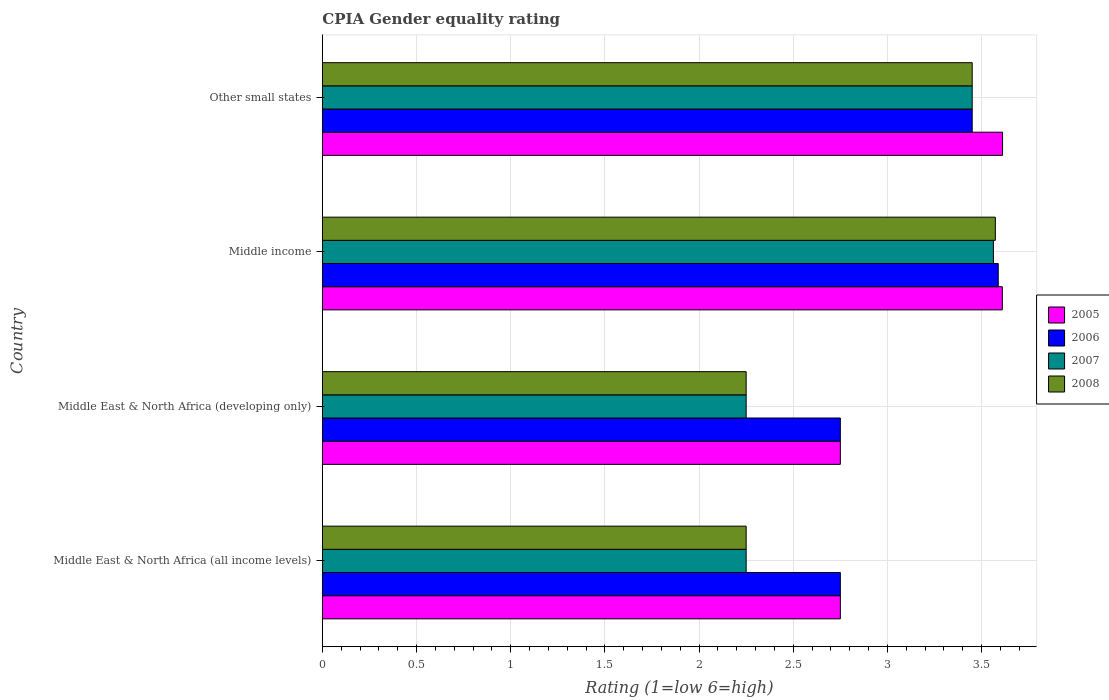How many groups of bars are there?
Offer a very short reply. 4. Are the number of bars per tick equal to the number of legend labels?
Keep it short and to the point. Yes. Are the number of bars on each tick of the Y-axis equal?
Provide a succinct answer. Yes. How many bars are there on the 2nd tick from the bottom?
Provide a short and direct response. 4. What is the label of the 1st group of bars from the top?
Provide a short and direct response. Other small states. What is the CPIA rating in 2008 in Middle East & North Africa (all income levels)?
Offer a very short reply. 2.25. Across all countries, what is the maximum CPIA rating in 2006?
Your answer should be compact. 3.59. Across all countries, what is the minimum CPIA rating in 2006?
Your answer should be compact. 2.75. In which country was the CPIA rating in 2008 minimum?
Provide a short and direct response. Middle East & North Africa (all income levels). What is the total CPIA rating in 2008 in the graph?
Offer a terse response. 11.52. What is the difference between the CPIA rating in 2005 in Middle East & North Africa (developing only) and that in Other small states?
Keep it short and to the point. -0.86. What is the difference between the CPIA rating in 2006 in Other small states and the CPIA rating in 2005 in Middle East & North Africa (developing only)?
Give a very brief answer. 0.7. What is the average CPIA rating in 2006 per country?
Offer a very short reply. 3.13. Is the difference between the CPIA rating in 2008 in Middle East & North Africa (all income levels) and Middle East & North Africa (developing only) greater than the difference between the CPIA rating in 2007 in Middle East & North Africa (all income levels) and Middle East & North Africa (developing only)?
Make the answer very short. No. What is the difference between the highest and the second highest CPIA rating in 2006?
Make the answer very short. 0.14. What is the difference between the highest and the lowest CPIA rating in 2005?
Offer a terse response. 0.86. Is it the case that in every country, the sum of the CPIA rating in 2007 and CPIA rating in 2006 is greater than the sum of CPIA rating in 2005 and CPIA rating in 2008?
Keep it short and to the point. Yes. What does the 1st bar from the top in Middle East & North Africa (developing only) represents?
Make the answer very short. 2008. What does the 4th bar from the bottom in Other small states represents?
Ensure brevity in your answer.  2008. Is it the case that in every country, the sum of the CPIA rating in 2006 and CPIA rating in 2008 is greater than the CPIA rating in 2007?
Your response must be concise. Yes. How many bars are there?
Ensure brevity in your answer.  16. What is the difference between two consecutive major ticks on the X-axis?
Your answer should be very brief. 0.5. Are the values on the major ticks of X-axis written in scientific E-notation?
Give a very brief answer. No. Does the graph contain any zero values?
Offer a terse response. No. Where does the legend appear in the graph?
Give a very brief answer. Center right. What is the title of the graph?
Provide a short and direct response. CPIA Gender equality rating. What is the Rating (1=low 6=high) in 2005 in Middle East & North Africa (all income levels)?
Provide a short and direct response. 2.75. What is the Rating (1=low 6=high) in 2006 in Middle East & North Africa (all income levels)?
Provide a short and direct response. 2.75. What is the Rating (1=low 6=high) of 2007 in Middle East & North Africa (all income levels)?
Ensure brevity in your answer.  2.25. What is the Rating (1=low 6=high) in 2008 in Middle East & North Africa (all income levels)?
Give a very brief answer. 2.25. What is the Rating (1=low 6=high) in 2005 in Middle East & North Africa (developing only)?
Offer a very short reply. 2.75. What is the Rating (1=low 6=high) of 2006 in Middle East & North Africa (developing only)?
Make the answer very short. 2.75. What is the Rating (1=low 6=high) in 2007 in Middle East & North Africa (developing only)?
Provide a short and direct response. 2.25. What is the Rating (1=low 6=high) in 2008 in Middle East & North Africa (developing only)?
Ensure brevity in your answer.  2.25. What is the Rating (1=low 6=high) in 2005 in Middle income?
Make the answer very short. 3.61. What is the Rating (1=low 6=high) of 2006 in Middle income?
Offer a terse response. 3.59. What is the Rating (1=low 6=high) in 2007 in Middle income?
Your answer should be compact. 3.56. What is the Rating (1=low 6=high) in 2008 in Middle income?
Provide a succinct answer. 3.57. What is the Rating (1=low 6=high) in 2005 in Other small states?
Offer a very short reply. 3.61. What is the Rating (1=low 6=high) of 2006 in Other small states?
Ensure brevity in your answer.  3.45. What is the Rating (1=low 6=high) of 2007 in Other small states?
Provide a short and direct response. 3.45. What is the Rating (1=low 6=high) of 2008 in Other small states?
Offer a terse response. 3.45. Across all countries, what is the maximum Rating (1=low 6=high) of 2005?
Offer a terse response. 3.61. Across all countries, what is the maximum Rating (1=low 6=high) in 2006?
Provide a short and direct response. 3.59. Across all countries, what is the maximum Rating (1=low 6=high) in 2007?
Keep it short and to the point. 3.56. Across all countries, what is the maximum Rating (1=low 6=high) of 2008?
Offer a very short reply. 3.57. Across all countries, what is the minimum Rating (1=low 6=high) in 2005?
Keep it short and to the point. 2.75. Across all countries, what is the minimum Rating (1=low 6=high) of 2006?
Your answer should be very brief. 2.75. Across all countries, what is the minimum Rating (1=low 6=high) of 2007?
Ensure brevity in your answer.  2.25. Across all countries, what is the minimum Rating (1=low 6=high) in 2008?
Your answer should be compact. 2.25. What is the total Rating (1=low 6=high) in 2005 in the graph?
Give a very brief answer. 12.72. What is the total Rating (1=low 6=high) of 2006 in the graph?
Ensure brevity in your answer.  12.54. What is the total Rating (1=low 6=high) in 2007 in the graph?
Make the answer very short. 11.51. What is the total Rating (1=low 6=high) in 2008 in the graph?
Your response must be concise. 11.52. What is the difference between the Rating (1=low 6=high) in 2005 in Middle East & North Africa (all income levels) and that in Middle income?
Your answer should be compact. -0.86. What is the difference between the Rating (1=low 6=high) of 2006 in Middle East & North Africa (all income levels) and that in Middle income?
Make the answer very short. -0.84. What is the difference between the Rating (1=low 6=high) in 2007 in Middle East & North Africa (all income levels) and that in Middle income?
Keep it short and to the point. -1.31. What is the difference between the Rating (1=low 6=high) of 2008 in Middle East & North Africa (all income levels) and that in Middle income?
Offer a terse response. -1.32. What is the difference between the Rating (1=low 6=high) of 2005 in Middle East & North Africa (all income levels) and that in Other small states?
Provide a short and direct response. -0.86. What is the difference between the Rating (1=low 6=high) in 2006 in Middle East & North Africa (all income levels) and that in Other small states?
Provide a succinct answer. -0.7. What is the difference between the Rating (1=low 6=high) of 2005 in Middle East & North Africa (developing only) and that in Middle income?
Offer a terse response. -0.86. What is the difference between the Rating (1=low 6=high) in 2006 in Middle East & North Africa (developing only) and that in Middle income?
Your answer should be very brief. -0.84. What is the difference between the Rating (1=low 6=high) of 2007 in Middle East & North Africa (developing only) and that in Middle income?
Your response must be concise. -1.31. What is the difference between the Rating (1=low 6=high) in 2008 in Middle East & North Africa (developing only) and that in Middle income?
Provide a succinct answer. -1.32. What is the difference between the Rating (1=low 6=high) in 2005 in Middle East & North Africa (developing only) and that in Other small states?
Ensure brevity in your answer.  -0.86. What is the difference between the Rating (1=low 6=high) in 2008 in Middle East & North Africa (developing only) and that in Other small states?
Ensure brevity in your answer.  -1.2. What is the difference between the Rating (1=low 6=high) of 2005 in Middle income and that in Other small states?
Offer a very short reply. -0. What is the difference between the Rating (1=low 6=high) in 2006 in Middle income and that in Other small states?
Your response must be concise. 0.14. What is the difference between the Rating (1=low 6=high) in 2007 in Middle income and that in Other small states?
Provide a short and direct response. 0.11. What is the difference between the Rating (1=low 6=high) in 2008 in Middle income and that in Other small states?
Your answer should be compact. 0.12. What is the difference between the Rating (1=low 6=high) of 2005 in Middle East & North Africa (all income levels) and the Rating (1=low 6=high) of 2007 in Middle East & North Africa (developing only)?
Ensure brevity in your answer.  0.5. What is the difference between the Rating (1=low 6=high) of 2007 in Middle East & North Africa (all income levels) and the Rating (1=low 6=high) of 2008 in Middle East & North Africa (developing only)?
Your response must be concise. 0. What is the difference between the Rating (1=low 6=high) in 2005 in Middle East & North Africa (all income levels) and the Rating (1=low 6=high) in 2006 in Middle income?
Offer a very short reply. -0.84. What is the difference between the Rating (1=low 6=high) of 2005 in Middle East & North Africa (all income levels) and the Rating (1=low 6=high) of 2007 in Middle income?
Make the answer very short. -0.81. What is the difference between the Rating (1=low 6=high) in 2005 in Middle East & North Africa (all income levels) and the Rating (1=low 6=high) in 2008 in Middle income?
Your answer should be compact. -0.82. What is the difference between the Rating (1=low 6=high) of 2006 in Middle East & North Africa (all income levels) and the Rating (1=low 6=high) of 2007 in Middle income?
Offer a very short reply. -0.81. What is the difference between the Rating (1=low 6=high) in 2006 in Middle East & North Africa (all income levels) and the Rating (1=low 6=high) in 2008 in Middle income?
Offer a very short reply. -0.82. What is the difference between the Rating (1=low 6=high) of 2007 in Middle East & North Africa (all income levels) and the Rating (1=low 6=high) of 2008 in Middle income?
Provide a succinct answer. -1.32. What is the difference between the Rating (1=low 6=high) of 2005 in Middle East & North Africa (all income levels) and the Rating (1=low 6=high) of 2006 in Other small states?
Give a very brief answer. -0.7. What is the difference between the Rating (1=low 6=high) in 2005 in Middle East & North Africa (all income levels) and the Rating (1=low 6=high) in 2007 in Other small states?
Your answer should be compact. -0.7. What is the difference between the Rating (1=low 6=high) of 2005 in Middle East & North Africa (all income levels) and the Rating (1=low 6=high) of 2008 in Other small states?
Offer a very short reply. -0.7. What is the difference between the Rating (1=low 6=high) in 2006 in Middle East & North Africa (all income levels) and the Rating (1=low 6=high) in 2007 in Other small states?
Give a very brief answer. -0.7. What is the difference between the Rating (1=low 6=high) in 2005 in Middle East & North Africa (developing only) and the Rating (1=low 6=high) in 2006 in Middle income?
Provide a succinct answer. -0.84. What is the difference between the Rating (1=low 6=high) in 2005 in Middle East & North Africa (developing only) and the Rating (1=low 6=high) in 2007 in Middle income?
Your answer should be compact. -0.81. What is the difference between the Rating (1=low 6=high) of 2005 in Middle East & North Africa (developing only) and the Rating (1=low 6=high) of 2008 in Middle income?
Give a very brief answer. -0.82. What is the difference between the Rating (1=low 6=high) of 2006 in Middle East & North Africa (developing only) and the Rating (1=low 6=high) of 2007 in Middle income?
Ensure brevity in your answer.  -0.81. What is the difference between the Rating (1=low 6=high) of 2006 in Middle East & North Africa (developing only) and the Rating (1=low 6=high) of 2008 in Middle income?
Give a very brief answer. -0.82. What is the difference between the Rating (1=low 6=high) in 2007 in Middle East & North Africa (developing only) and the Rating (1=low 6=high) in 2008 in Middle income?
Your answer should be very brief. -1.32. What is the difference between the Rating (1=low 6=high) of 2005 in Middle East & North Africa (developing only) and the Rating (1=low 6=high) of 2007 in Other small states?
Offer a terse response. -0.7. What is the difference between the Rating (1=low 6=high) in 2006 in Middle East & North Africa (developing only) and the Rating (1=low 6=high) in 2008 in Other small states?
Give a very brief answer. -0.7. What is the difference between the Rating (1=low 6=high) in 2005 in Middle income and the Rating (1=low 6=high) in 2006 in Other small states?
Your answer should be very brief. 0.16. What is the difference between the Rating (1=low 6=high) in 2005 in Middle income and the Rating (1=low 6=high) in 2007 in Other small states?
Your response must be concise. 0.16. What is the difference between the Rating (1=low 6=high) of 2005 in Middle income and the Rating (1=low 6=high) of 2008 in Other small states?
Offer a very short reply. 0.16. What is the difference between the Rating (1=low 6=high) of 2006 in Middle income and the Rating (1=low 6=high) of 2007 in Other small states?
Offer a very short reply. 0.14. What is the difference between the Rating (1=low 6=high) in 2006 in Middle income and the Rating (1=low 6=high) in 2008 in Other small states?
Offer a terse response. 0.14. What is the difference between the Rating (1=low 6=high) of 2007 in Middle income and the Rating (1=low 6=high) of 2008 in Other small states?
Your answer should be compact. 0.11. What is the average Rating (1=low 6=high) of 2005 per country?
Your answer should be compact. 3.18. What is the average Rating (1=low 6=high) in 2006 per country?
Offer a very short reply. 3.13. What is the average Rating (1=low 6=high) of 2007 per country?
Your response must be concise. 2.88. What is the average Rating (1=low 6=high) in 2008 per country?
Make the answer very short. 2.88. What is the difference between the Rating (1=low 6=high) of 2005 and Rating (1=low 6=high) of 2008 in Middle East & North Africa (all income levels)?
Your answer should be very brief. 0.5. What is the difference between the Rating (1=low 6=high) of 2006 and Rating (1=low 6=high) of 2007 in Middle East & North Africa (all income levels)?
Make the answer very short. 0.5. What is the difference between the Rating (1=low 6=high) in 2006 and Rating (1=low 6=high) in 2008 in Middle East & North Africa (all income levels)?
Make the answer very short. 0.5. What is the difference between the Rating (1=low 6=high) of 2005 and Rating (1=low 6=high) of 2006 in Middle East & North Africa (developing only)?
Provide a short and direct response. 0. What is the difference between the Rating (1=low 6=high) in 2005 and Rating (1=low 6=high) in 2008 in Middle East & North Africa (developing only)?
Provide a short and direct response. 0.5. What is the difference between the Rating (1=low 6=high) of 2006 and Rating (1=low 6=high) of 2008 in Middle East & North Africa (developing only)?
Your answer should be compact. 0.5. What is the difference between the Rating (1=low 6=high) of 2005 and Rating (1=low 6=high) of 2006 in Middle income?
Give a very brief answer. 0.02. What is the difference between the Rating (1=low 6=high) in 2005 and Rating (1=low 6=high) in 2007 in Middle income?
Give a very brief answer. 0.05. What is the difference between the Rating (1=low 6=high) in 2005 and Rating (1=low 6=high) in 2008 in Middle income?
Provide a short and direct response. 0.04. What is the difference between the Rating (1=low 6=high) in 2006 and Rating (1=low 6=high) in 2007 in Middle income?
Your response must be concise. 0.03. What is the difference between the Rating (1=low 6=high) of 2006 and Rating (1=low 6=high) of 2008 in Middle income?
Provide a short and direct response. 0.02. What is the difference between the Rating (1=low 6=high) in 2007 and Rating (1=low 6=high) in 2008 in Middle income?
Offer a very short reply. -0.01. What is the difference between the Rating (1=low 6=high) of 2005 and Rating (1=low 6=high) of 2006 in Other small states?
Give a very brief answer. 0.16. What is the difference between the Rating (1=low 6=high) of 2005 and Rating (1=low 6=high) of 2007 in Other small states?
Provide a short and direct response. 0.16. What is the difference between the Rating (1=low 6=high) in 2005 and Rating (1=low 6=high) in 2008 in Other small states?
Your response must be concise. 0.16. What is the difference between the Rating (1=low 6=high) in 2006 and Rating (1=low 6=high) in 2007 in Other small states?
Ensure brevity in your answer.  0. What is the difference between the Rating (1=low 6=high) in 2006 and Rating (1=low 6=high) in 2008 in Other small states?
Make the answer very short. 0. What is the ratio of the Rating (1=low 6=high) in 2005 in Middle East & North Africa (all income levels) to that in Middle East & North Africa (developing only)?
Ensure brevity in your answer.  1. What is the ratio of the Rating (1=low 6=high) in 2006 in Middle East & North Africa (all income levels) to that in Middle East & North Africa (developing only)?
Keep it short and to the point. 1. What is the ratio of the Rating (1=low 6=high) in 2008 in Middle East & North Africa (all income levels) to that in Middle East & North Africa (developing only)?
Give a very brief answer. 1. What is the ratio of the Rating (1=low 6=high) in 2005 in Middle East & North Africa (all income levels) to that in Middle income?
Your answer should be very brief. 0.76. What is the ratio of the Rating (1=low 6=high) of 2006 in Middle East & North Africa (all income levels) to that in Middle income?
Ensure brevity in your answer.  0.77. What is the ratio of the Rating (1=low 6=high) of 2007 in Middle East & North Africa (all income levels) to that in Middle income?
Offer a terse response. 0.63. What is the ratio of the Rating (1=low 6=high) in 2008 in Middle East & North Africa (all income levels) to that in Middle income?
Provide a succinct answer. 0.63. What is the ratio of the Rating (1=low 6=high) of 2005 in Middle East & North Africa (all income levels) to that in Other small states?
Your answer should be compact. 0.76. What is the ratio of the Rating (1=low 6=high) of 2006 in Middle East & North Africa (all income levels) to that in Other small states?
Give a very brief answer. 0.8. What is the ratio of the Rating (1=low 6=high) in 2007 in Middle East & North Africa (all income levels) to that in Other small states?
Keep it short and to the point. 0.65. What is the ratio of the Rating (1=low 6=high) in 2008 in Middle East & North Africa (all income levels) to that in Other small states?
Your response must be concise. 0.65. What is the ratio of the Rating (1=low 6=high) in 2005 in Middle East & North Africa (developing only) to that in Middle income?
Your answer should be very brief. 0.76. What is the ratio of the Rating (1=low 6=high) of 2006 in Middle East & North Africa (developing only) to that in Middle income?
Offer a very short reply. 0.77. What is the ratio of the Rating (1=low 6=high) of 2007 in Middle East & North Africa (developing only) to that in Middle income?
Your response must be concise. 0.63. What is the ratio of the Rating (1=low 6=high) of 2008 in Middle East & North Africa (developing only) to that in Middle income?
Provide a short and direct response. 0.63. What is the ratio of the Rating (1=low 6=high) of 2005 in Middle East & North Africa (developing only) to that in Other small states?
Your response must be concise. 0.76. What is the ratio of the Rating (1=low 6=high) of 2006 in Middle East & North Africa (developing only) to that in Other small states?
Provide a succinct answer. 0.8. What is the ratio of the Rating (1=low 6=high) of 2007 in Middle East & North Africa (developing only) to that in Other small states?
Keep it short and to the point. 0.65. What is the ratio of the Rating (1=low 6=high) of 2008 in Middle East & North Africa (developing only) to that in Other small states?
Make the answer very short. 0.65. What is the ratio of the Rating (1=low 6=high) of 2006 in Middle income to that in Other small states?
Give a very brief answer. 1.04. What is the ratio of the Rating (1=low 6=high) in 2007 in Middle income to that in Other small states?
Your answer should be very brief. 1.03. What is the ratio of the Rating (1=low 6=high) in 2008 in Middle income to that in Other small states?
Keep it short and to the point. 1.04. What is the difference between the highest and the second highest Rating (1=low 6=high) of 2005?
Give a very brief answer. 0. What is the difference between the highest and the second highest Rating (1=low 6=high) of 2006?
Provide a succinct answer. 0.14. What is the difference between the highest and the second highest Rating (1=low 6=high) in 2007?
Your answer should be very brief. 0.11. What is the difference between the highest and the second highest Rating (1=low 6=high) in 2008?
Provide a short and direct response. 0.12. What is the difference between the highest and the lowest Rating (1=low 6=high) in 2005?
Offer a terse response. 0.86. What is the difference between the highest and the lowest Rating (1=low 6=high) of 2006?
Offer a very short reply. 0.84. What is the difference between the highest and the lowest Rating (1=low 6=high) in 2007?
Provide a succinct answer. 1.31. What is the difference between the highest and the lowest Rating (1=low 6=high) of 2008?
Your answer should be compact. 1.32. 